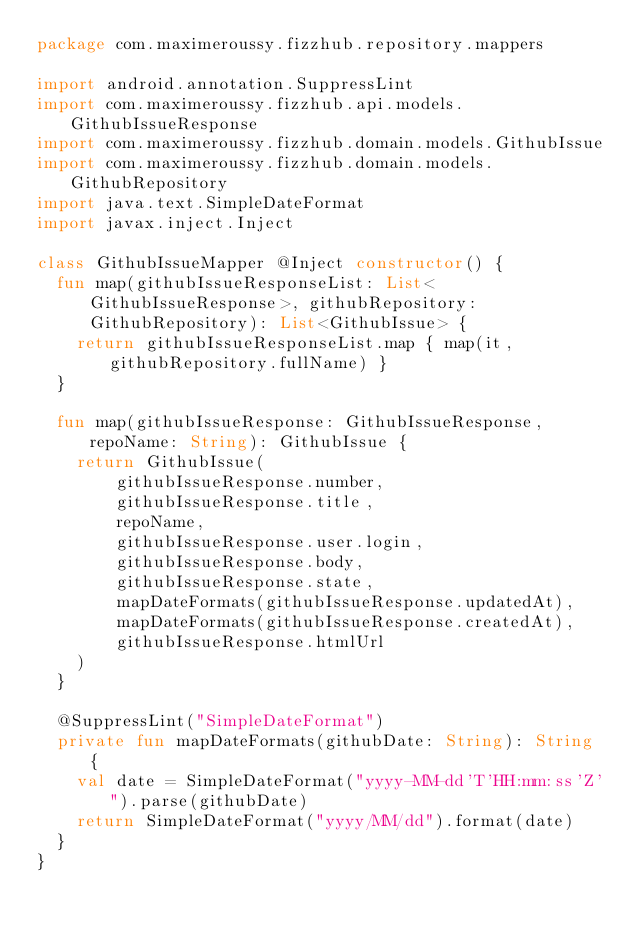<code> <loc_0><loc_0><loc_500><loc_500><_Kotlin_>package com.maximeroussy.fizzhub.repository.mappers

import android.annotation.SuppressLint
import com.maximeroussy.fizzhub.api.models.GithubIssueResponse
import com.maximeroussy.fizzhub.domain.models.GithubIssue
import com.maximeroussy.fizzhub.domain.models.GithubRepository
import java.text.SimpleDateFormat
import javax.inject.Inject

class GithubIssueMapper @Inject constructor() {
  fun map(githubIssueResponseList: List<GithubIssueResponse>, githubRepository: GithubRepository): List<GithubIssue> {
    return githubIssueResponseList.map { map(it, githubRepository.fullName) }
  }

  fun map(githubIssueResponse: GithubIssueResponse, repoName: String): GithubIssue {
    return GithubIssue(
        githubIssueResponse.number,
        githubIssueResponse.title,
        repoName,
        githubIssueResponse.user.login,
        githubIssueResponse.body,
        githubIssueResponse.state,
        mapDateFormats(githubIssueResponse.updatedAt),
        mapDateFormats(githubIssueResponse.createdAt),
        githubIssueResponse.htmlUrl
    )
  }

  @SuppressLint("SimpleDateFormat")
  private fun mapDateFormats(githubDate: String): String {
    val date = SimpleDateFormat("yyyy-MM-dd'T'HH:mm:ss'Z'").parse(githubDate)
    return SimpleDateFormat("yyyy/MM/dd").format(date)
  }
}
</code> 